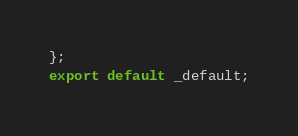Convert code to text. <code><loc_0><loc_0><loc_500><loc_500><_TypeScript_>};
export default _default;
</code> 